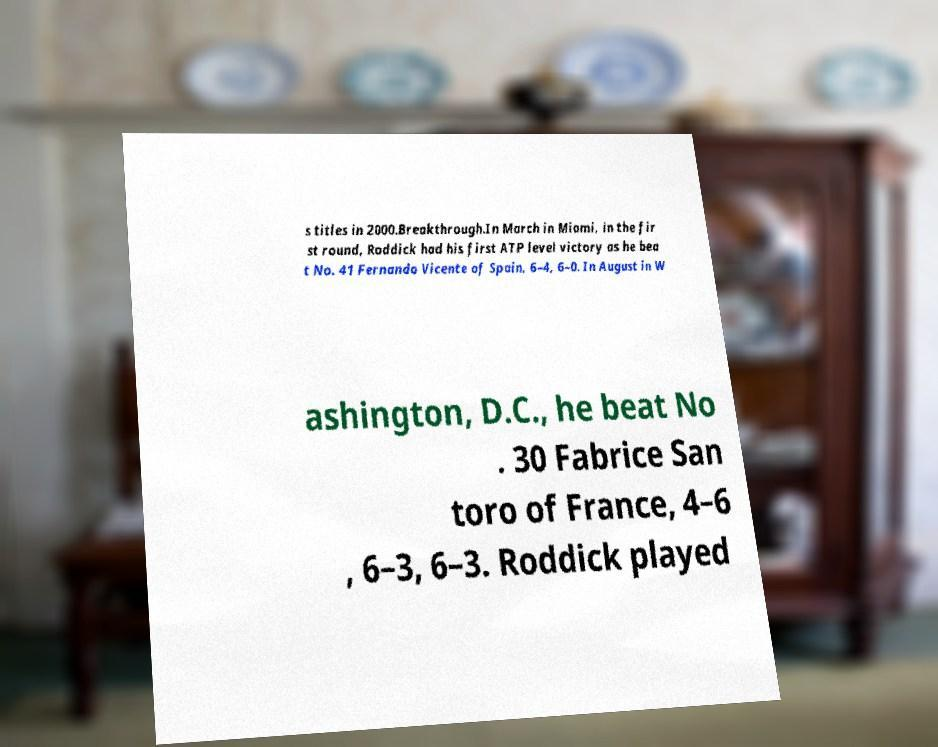Can you read and provide the text displayed in the image?This photo seems to have some interesting text. Can you extract and type it out for me? s titles in 2000.Breakthrough.In March in Miami, in the fir st round, Roddick had his first ATP level victory as he bea t No. 41 Fernando Vicente of Spain, 6–4, 6–0. In August in W ashington, D.C., he beat No . 30 Fabrice San toro of France, 4–6 , 6–3, 6–3. Roddick played 